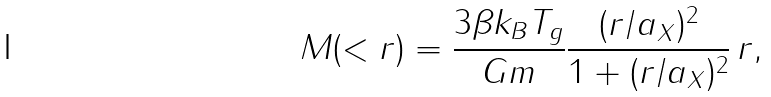<formula> <loc_0><loc_0><loc_500><loc_500>M ( < r ) = \frac { 3 \beta k _ { B } T _ { g } } { G m } \frac { ( r / a _ { X } ) ^ { 2 } } { 1 + ( r / a _ { X } ) ^ { 2 } } \, r ,</formula> 